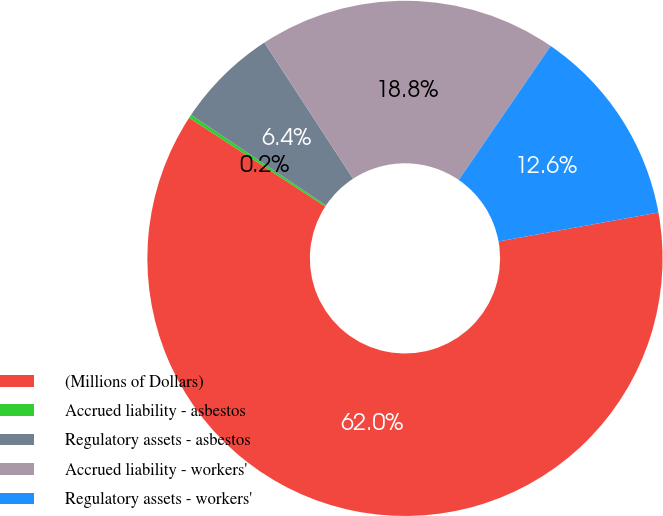<chart> <loc_0><loc_0><loc_500><loc_500><pie_chart><fcel>(Millions of Dollars)<fcel>Accrued liability - asbestos<fcel>Regulatory assets - asbestos<fcel>Accrued liability - workers'<fcel>Regulatory assets - workers'<nl><fcel>62.04%<fcel>0.22%<fcel>6.4%<fcel>18.76%<fcel>12.58%<nl></chart> 